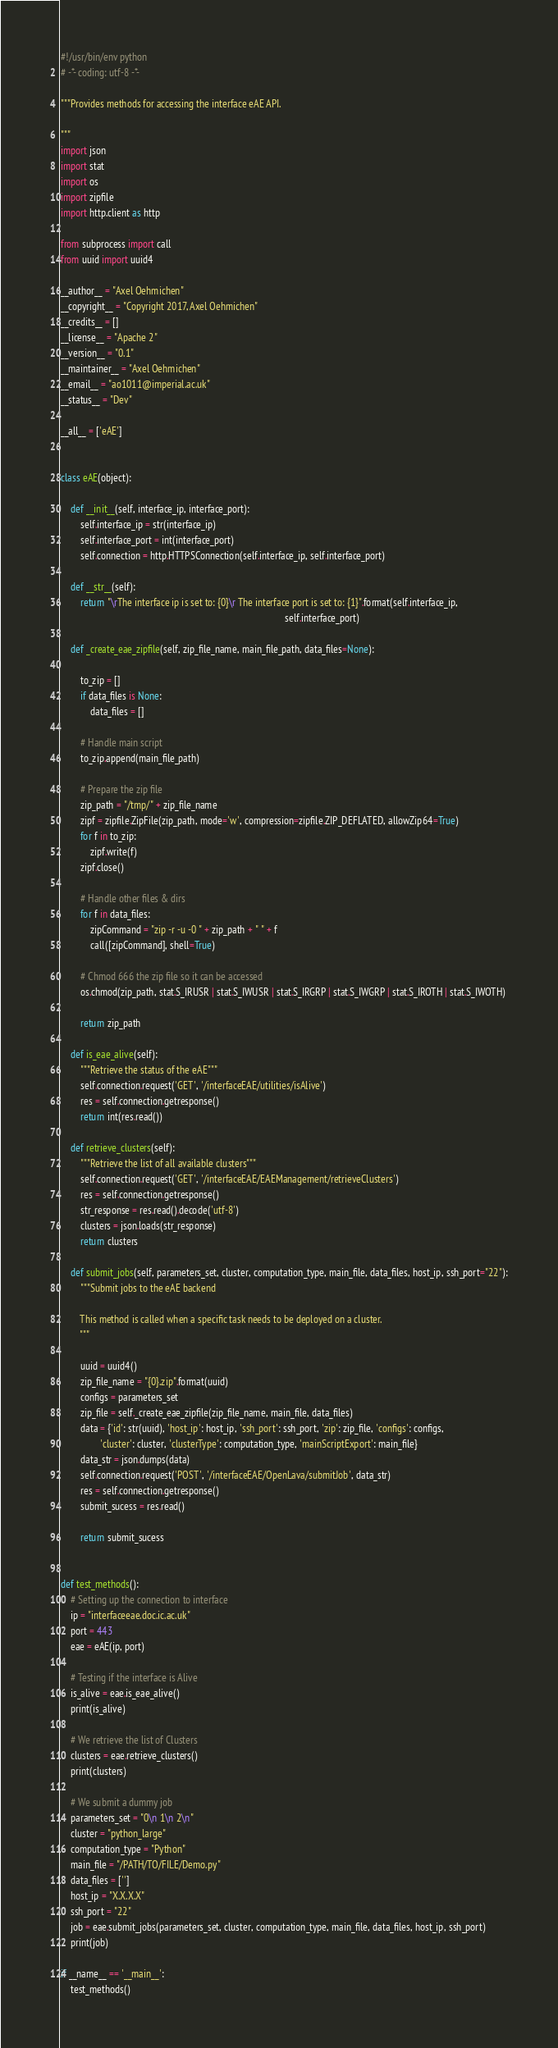<code> <loc_0><loc_0><loc_500><loc_500><_Python_>#!/usr/bin/env python
# -*- coding: utf-8 -*-

"""Provides methods for accessing the interface eAE API.

"""
import json
import stat
import os
import zipfile
import http.client as http

from subprocess import call
from uuid import uuid4

__author__ = "Axel Oehmichen"
__copyright__ = "Copyright 2017, Axel Oehmichen"
__credits__ = []
__license__ = "Apache 2"
__version__ = "0.1"
__maintainer__ = "Axel Oehmichen"
__email__ = "ao1011@imperial.ac.uk"
__status__ = "Dev"

__all__ = ['eAE']


class eAE(object):

    def __init__(self, interface_ip, interface_port):
        self.interface_ip = str(interface_ip)
        self.interface_port = int(interface_port)
        self.connection = http.HTTPSConnection(self.interface_ip, self.interface_port)

    def __str__(self):
        return "\rThe interface ip is set to: {0}\r The interface port is set to: {1}".format(self.interface_ip,
                                                                                            self.interface_port)

    def _create_eae_zipfile(self, zip_file_name, main_file_path, data_files=None):

        to_zip = []
        if data_files is None:
            data_files = []

        # Handle main script
        to_zip.append(main_file_path)

        # Prepare the zip file
        zip_path = "/tmp/" + zip_file_name
        zipf = zipfile.ZipFile(zip_path, mode='w', compression=zipfile.ZIP_DEFLATED, allowZip64=True)
        for f in to_zip:
            zipf.write(f)
        zipf.close()

        # Handle other files & dirs
        for f in data_files:
            zipCommand = "zip -r -u -0 " + zip_path + " " + f
            call([zipCommand], shell=True)

        # Chmod 666 the zip file so it can be accessed
        os.chmod(zip_path, stat.S_IRUSR | stat.S_IWUSR | stat.S_IRGRP | stat.S_IWGRP | stat.S_IROTH | stat.S_IWOTH)

        return zip_path

    def is_eae_alive(self):
        """Retrieve the status of the eAE"""
        self.connection.request('GET', '/interfaceEAE/utilities/isAlive')
        res = self.connection.getresponse()
        return int(res.read())

    def retrieve_clusters(self):
        """Retrieve the list of all available clusters"""
        self.connection.request('GET', '/interfaceEAE/EAEManagement/retrieveClusters')
        res = self.connection.getresponse()
        str_response = res.read().decode('utf-8')
        clusters = json.loads(str_response)
        return clusters

    def submit_jobs(self, parameters_set, cluster, computation_type, main_file, data_files, host_ip, ssh_port="22"):
        """Submit jobs to the eAE backend
        
        This method is called when a specific task needs to be deployed on a cluster.
        """

        uuid = uuid4()
        zip_file_name = "{0}.zip".format(uuid)
        configs = parameters_set
        zip_file = self._create_eae_zipfile(zip_file_name, main_file, data_files)
        data = {'id': str(uuid), 'host_ip': host_ip, 'ssh_port': ssh_port, 'zip': zip_file, 'configs': configs,
                'cluster': cluster, 'clusterType': computation_type, 'mainScriptExport': main_file}
        data_str = json.dumps(data)
        self.connection.request('POST', '/interfaceEAE/OpenLava/submitJob', data_str)
        res = self.connection.getresponse()
        submit_sucess = res.read()

        return submit_sucess


def test_methods():
    # Setting up the connection to interface
    ip = "interfaceeae.doc.ic.ac.uk"
    port = 443
    eae = eAE(ip, port)

    # Testing if the interface is Alive
    is_alive = eae.is_eae_alive()
    print(is_alive)

    # We retrieve the list of Clusters
    clusters = eae.retrieve_clusters()
    print(clusters)

    # We submit a dummy job
    parameters_set = "0\n 1\n 2\n"
    cluster = "python_large"
    computation_type = "Python"
    main_file = "/PATH/TO/FILE/Demo.py"
    data_files = ['']
    host_ip = "X.X.X.X"
    ssh_port = "22"
    job = eae.submit_jobs(parameters_set, cluster, computation_type, main_file, data_files, host_ip, ssh_port)
    print(job)

if __name__ == '__main__':
    test_methods()

</code> 